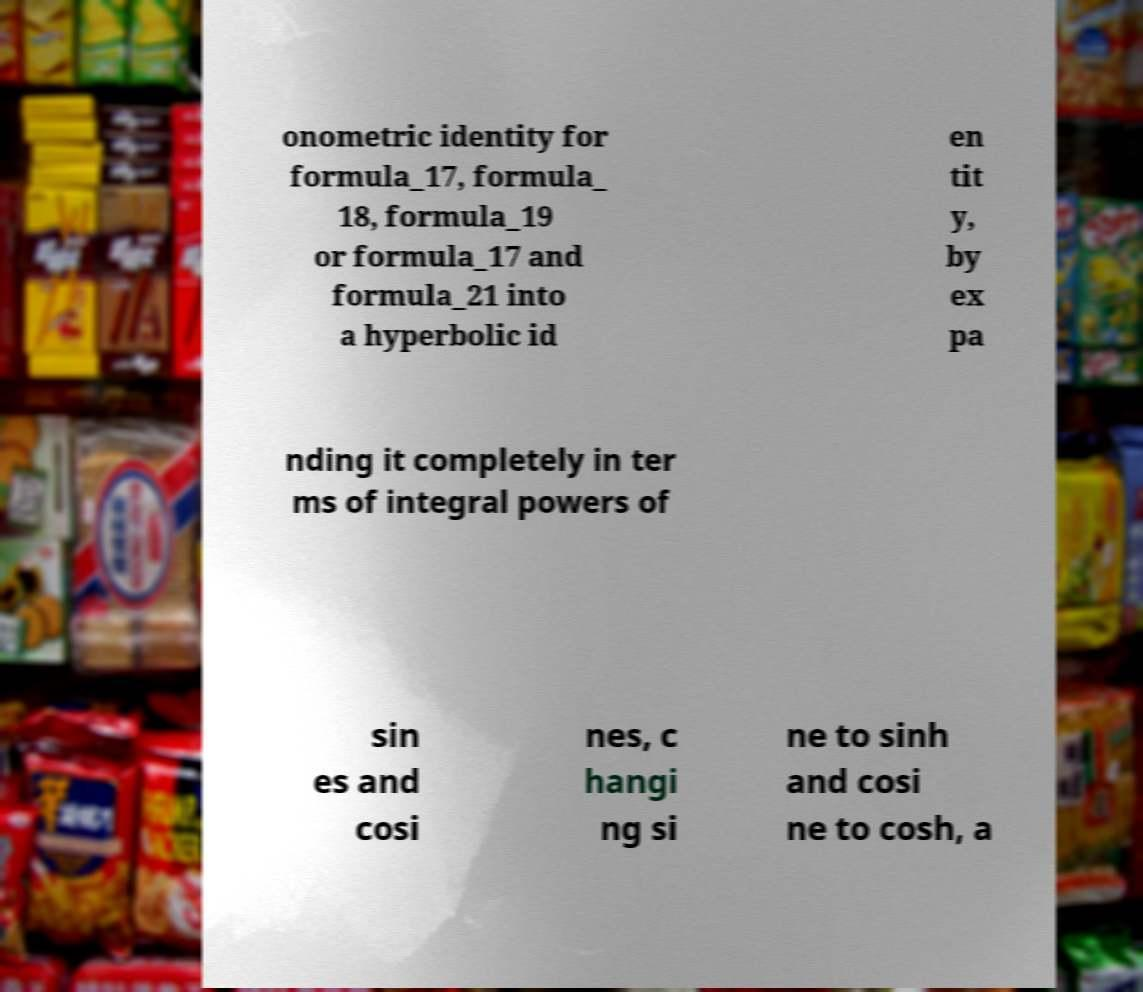Can you read and provide the text displayed in the image?This photo seems to have some interesting text. Can you extract and type it out for me? onometric identity for formula_17, formula_ 18, formula_19 or formula_17 and formula_21 into a hyperbolic id en tit y, by ex pa nding it completely in ter ms of integral powers of sin es and cosi nes, c hangi ng si ne to sinh and cosi ne to cosh, a 